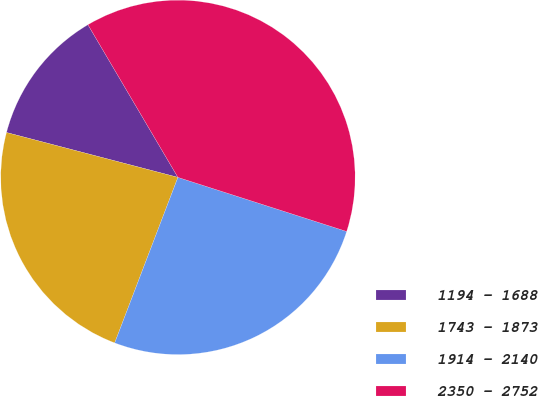Convert chart. <chart><loc_0><loc_0><loc_500><loc_500><pie_chart><fcel>1194 - 1688<fcel>1743 - 1873<fcel>1914 - 2140<fcel>2350 - 2752<nl><fcel>12.45%<fcel>23.27%<fcel>25.87%<fcel>38.42%<nl></chart> 